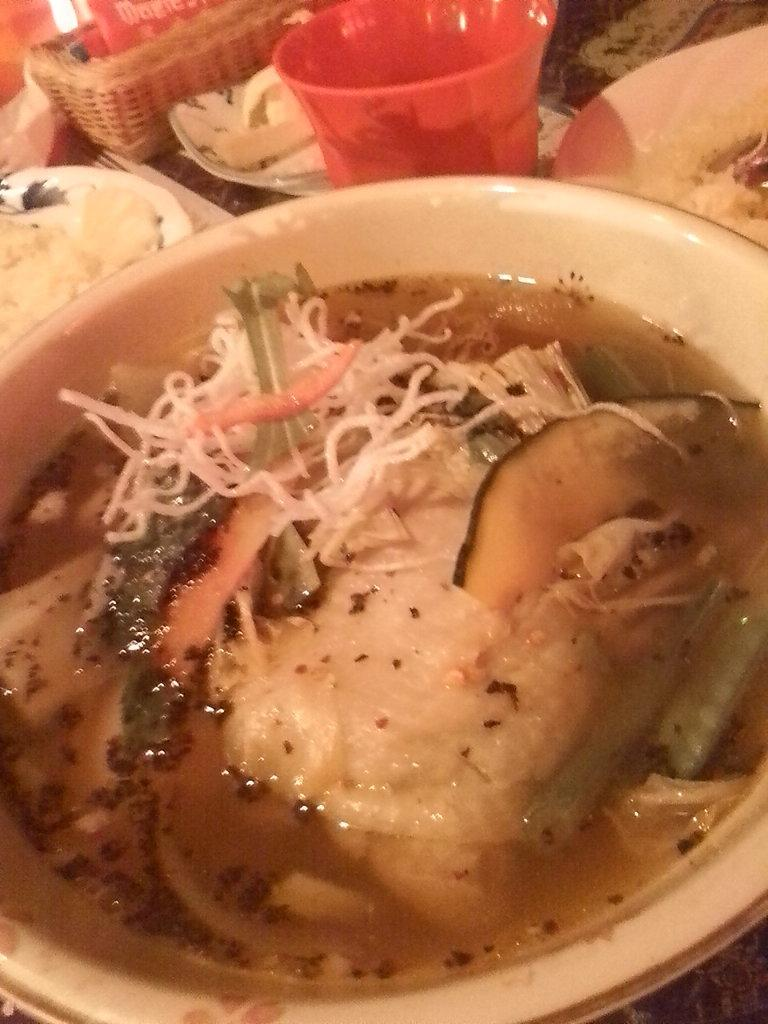What is in the bowl that is visible in the image? There is a bowl with curry and soup in the image. What type of glass can be seen in the image? There is a red color glass in the image. What else is present in the image besides the bowl and glass? There are plates with food in the image. How many dolls are sitting on the plates in the image? There are no dolls present in the image; it features a bowl with curry and soup, a red color glass, and plates with food. What direction is the eye facing in the image? There is no eye present in the image. 